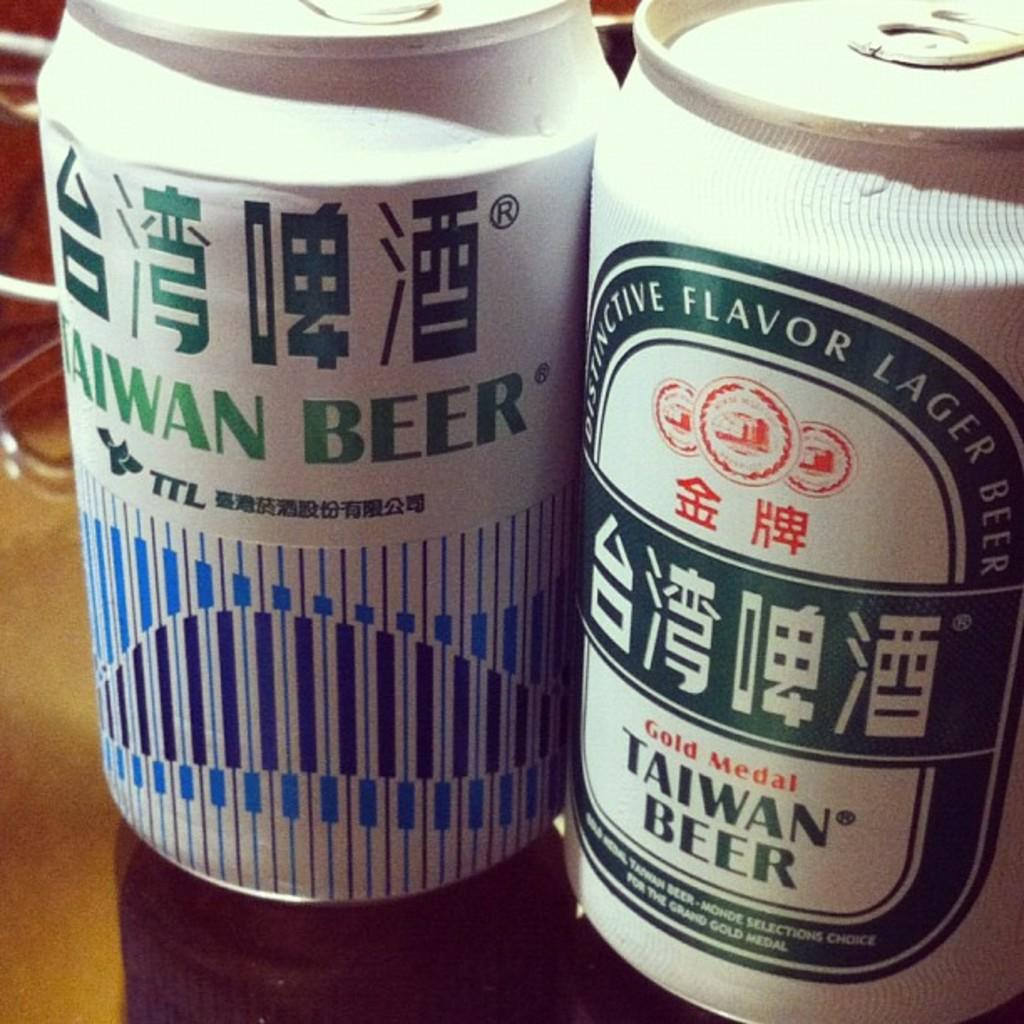<image>
Provide a brief description of the given image. Two cans of Taiwan Beer sitting on a table next to each other. 